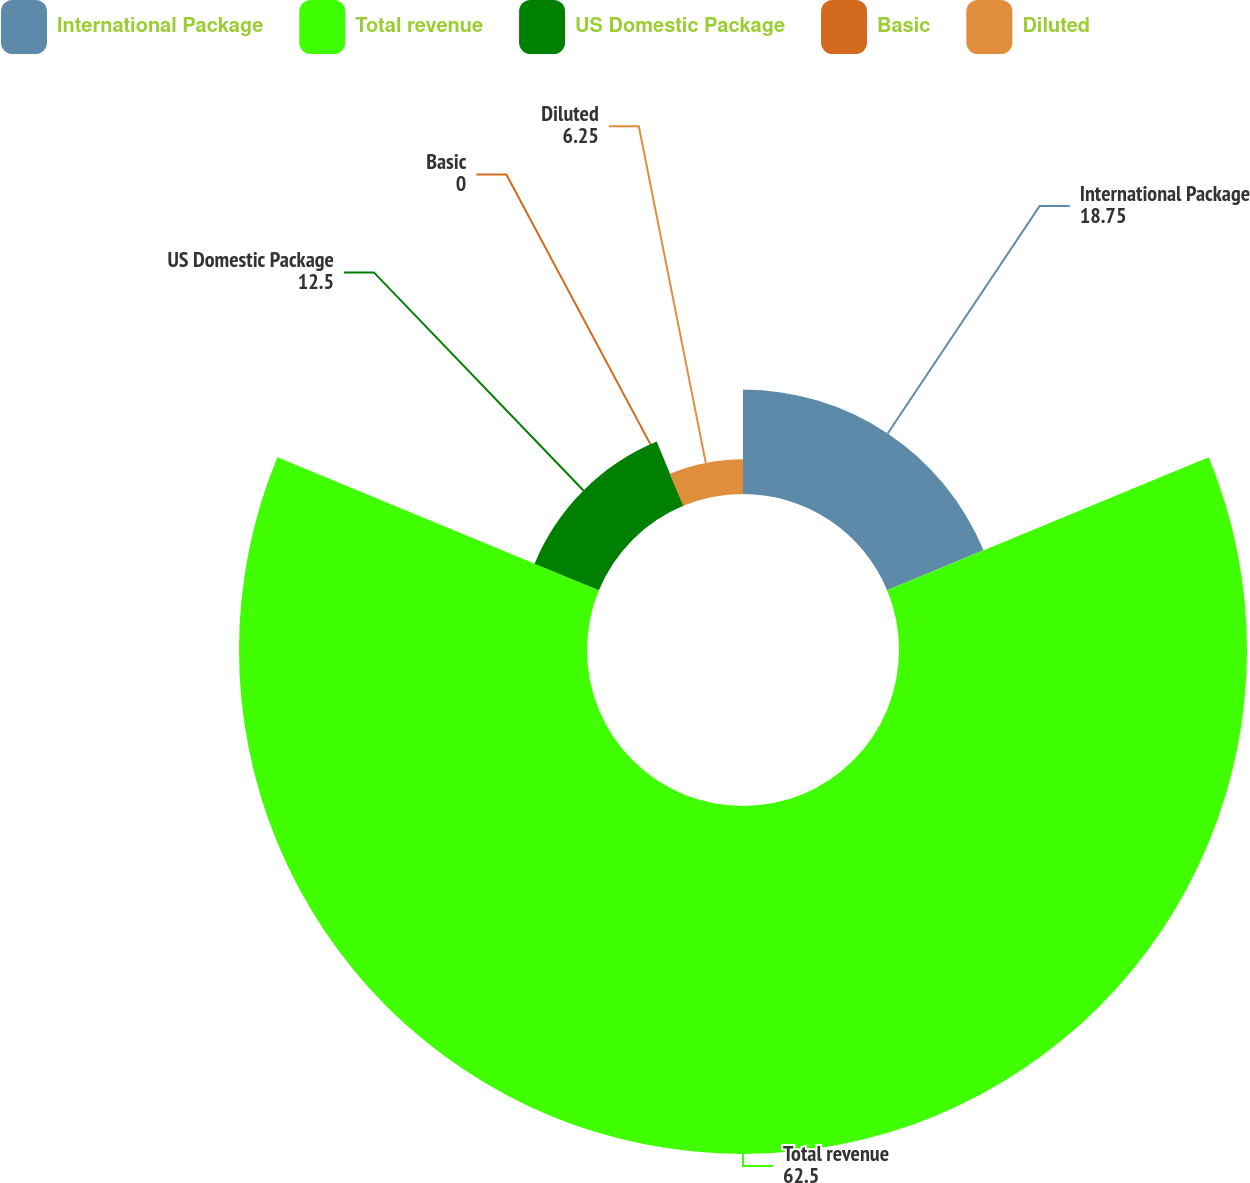Convert chart. <chart><loc_0><loc_0><loc_500><loc_500><pie_chart><fcel>International Package<fcel>Total revenue<fcel>US Domestic Package<fcel>Basic<fcel>Diluted<nl><fcel>18.75%<fcel>62.5%<fcel>12.5%<fcel>0.0%<fcel>6.25%<nl></chart> 